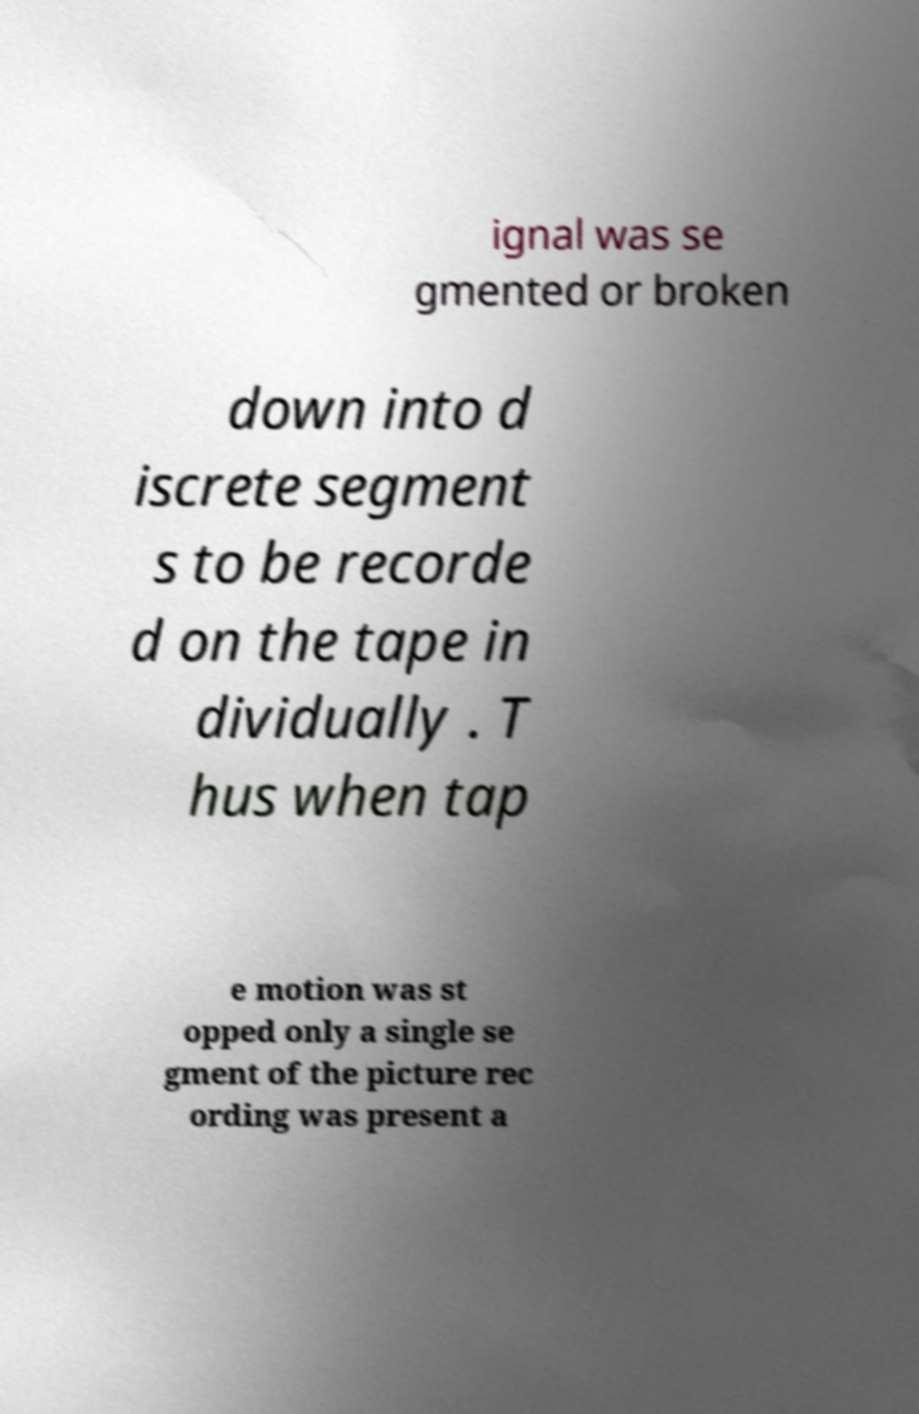I need the written content from this picture converted into text. Can you do that? ignal was se gmented or broken down into d iscrete segment s to be recorde d on the tape in dividually . T hus when tap e motion was st opped only a single se gment of the picture rec ording was present a 